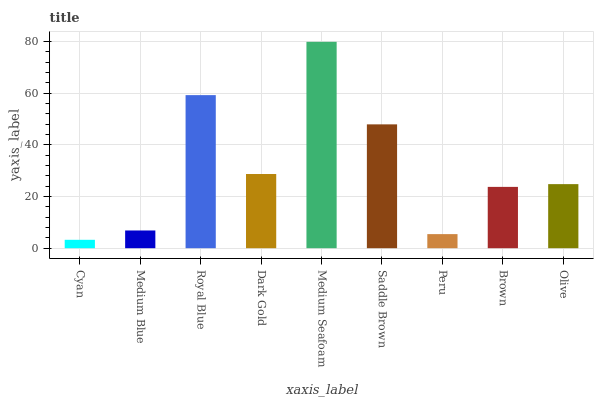Is Cyan the minimum?
Answer yes or no. Yes. Is Medium Seafoam the maximum?
Answer yes or no. Yes. Is Medium Blue the minimum?
Answer yes or no. No. Is Medium Blue the maximum?
Answer yes or no. No. Is Medium Blue greater than Cyan?
Answer yes or no. Yes. Is Cyan less than Medium Blue?
Answer yes or no. Yes. Is Cyan greater than Medium Blue?
Answer yes or no. No. Is Medium Blue less than Cyan?
Answer yes or no. No. Is Olive the high median?
Answer yes or no. Yes. Is Olive the low median?
Answer yes or no. Yes. Is Peru the high median?
Answer yes or no. No. Is Royal Blue the low median?
Answer yes or no. No. 